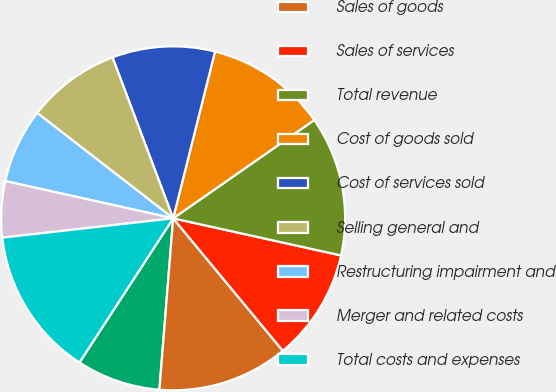Convert chart. <chart><loc_0><loc_0><loc_500><loc_500><pie_chart><fcel>(In millions except per share<fcel>Sales of goods<fcel>Sales of services<fcel>Total revenue<fcel>Cost of goods sold<fcel>Cost of services sold<fcel>Selling general and<fcel>Restructuring impairment and<fcel>Merger and related costs<fcel>Total costs and expenses<nl><fcel>7.9%<fcel>12.28%<fcel>10.53%<fcel>13.15%<fcel>11.4%<fcel>9.65%<fcel>8.77%<fcel>7.02%<fcel>5.27%<fcel>14.03%<nl></chart> 